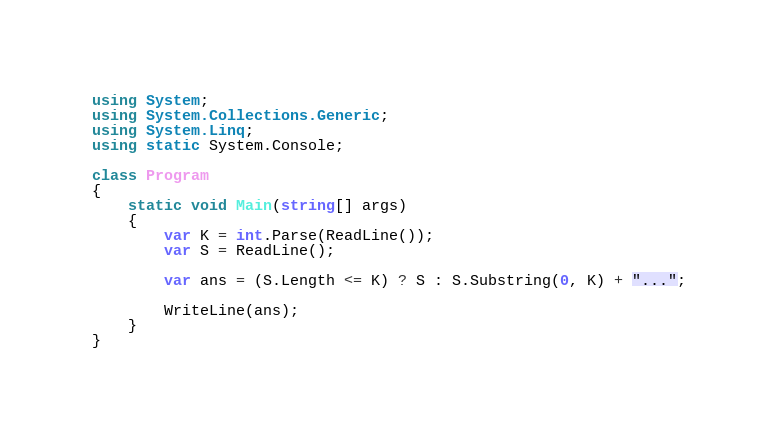<code> <loc_0><loc_0><loc_500><loc_500><_C#_>using System;
using System.Collections.Generic;
using System.Linq;
using static System.Console;

class Program
{
    static void Main(string[] args)
    {
        var K = int.Parse(ReadLine());
        var S = ReadLine();

        var ans = (S.Length <= K) ? S : S.Substring(0, K) + "...";

        WriteLine(ans);
    }
}</code> 